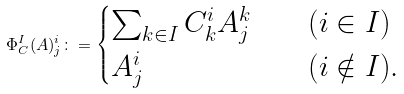<formula> <loc_0><loc_0><loc_500><loc_500>\Phi ^ { I } _ { C } ( A ) ^ { i } _ { j } \colon = \begin{cases} \sum _ { k \in I } C ^ { i } _ { k } A ^ { k } _ { j } \quad & \text {$(i\in I)$} \\ A ^ { i } _ { j } \quad & \text {$(i\notin I)$} . \end{cases}</formula> 